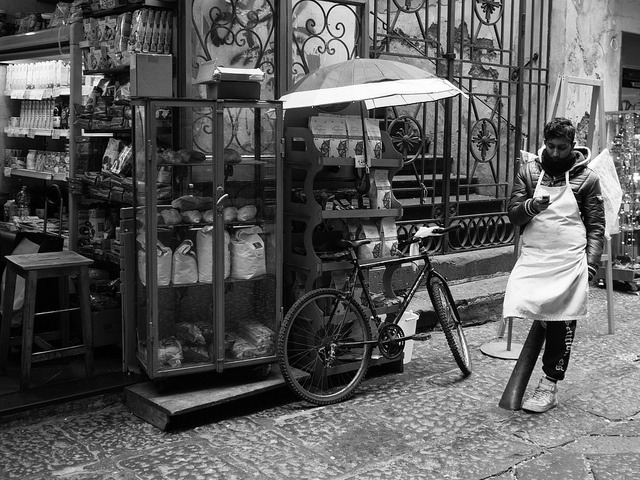Describe the objects in this image and their specific colors. I can see people in black, lightgray, darkgray, and gray tones, bicycle in black, gray, darkgray, and lightgray tones, chair in black and gray tones, umbrella in black, white, darkgray, and gray tones, and cell phone in black, gray, and lightgray tones in this image. 